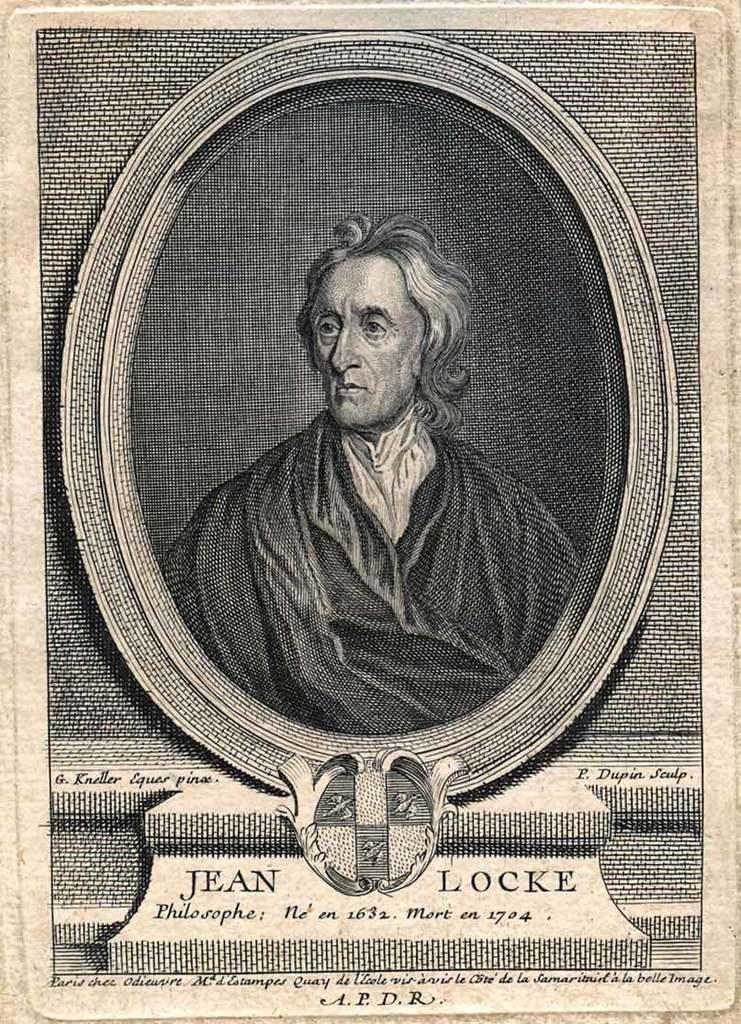<image>
Offer a succinct explanation of the picture presented. A portrait of Jean Locke who was a philosopher in 1632. 